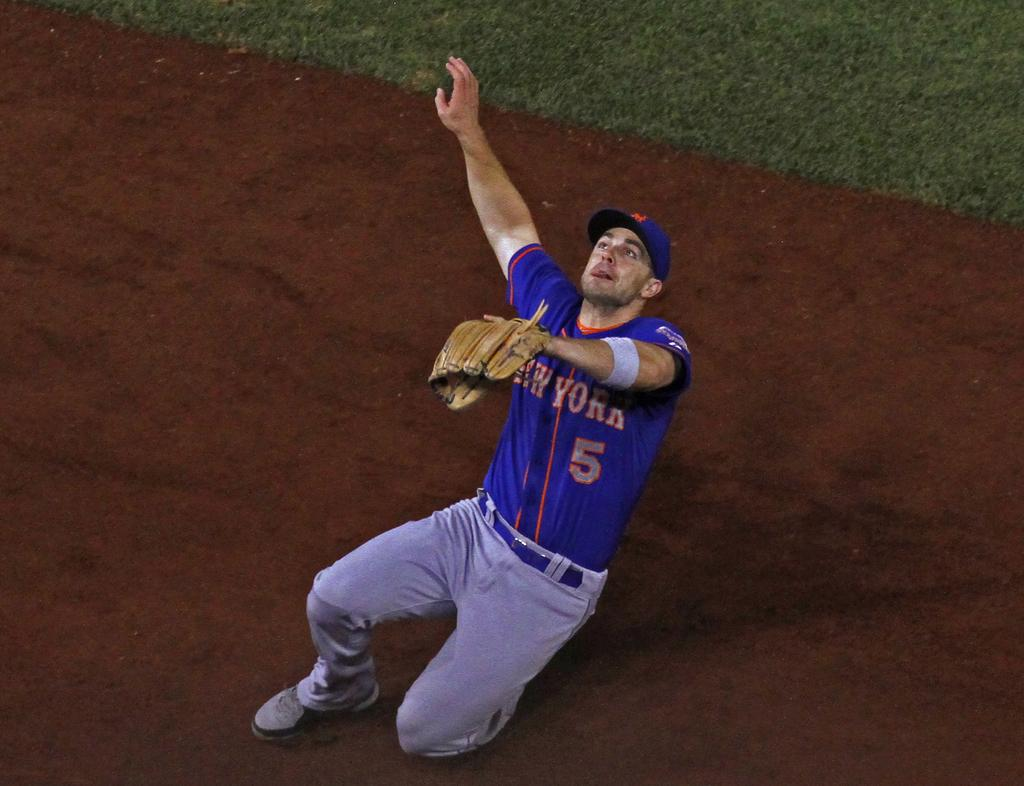Provide a one-sentence caption for the provided image. The New York Baseball player was actively participating in the sport. 